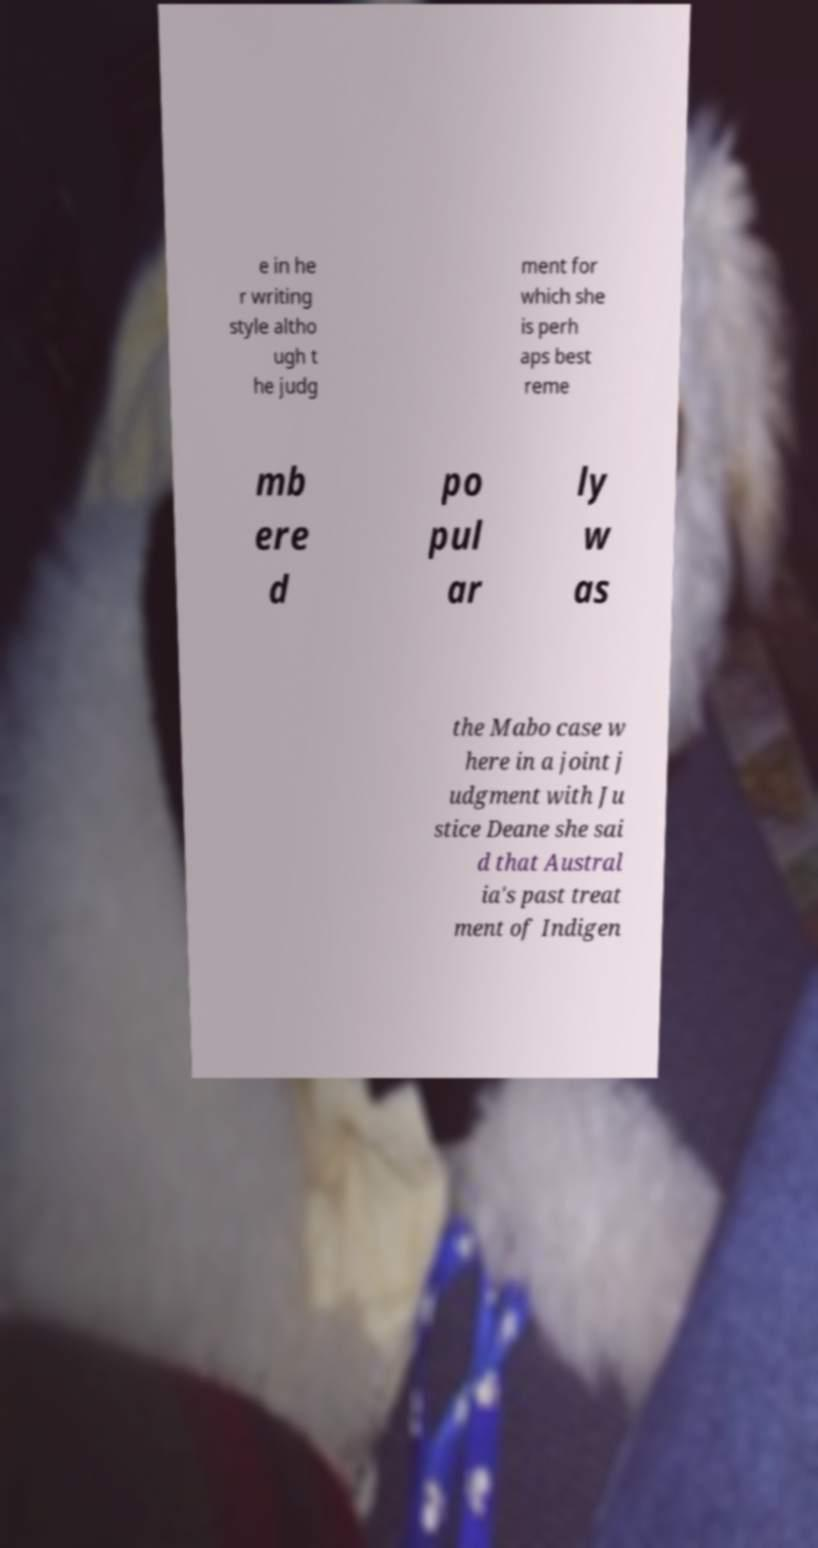Could you assist in decoding the text presented in this image and type it out clearly? e in he r writing style altho ugh t he judg ment for which she is perh aps best reme mb ere d po pul ar ly w as the Mabo case w here in a joint j udgment with Ju stice Deane she sai d that Austral ia's past treat ment of Indigen 